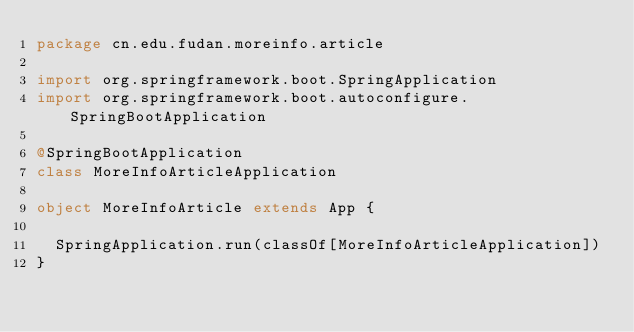Convert code to text. <code><loc_0><loc_0><loc_500><loc_500><_Scala_>package cn.edu.fudan.moreinfo.article

import org.springframework.boot.SpringApplication
import org.springframework.boot.autoconfigure.SpringBootApplication

@SpringBootApplication
class MoreInfoArticleApplication

object MoreInfoArticle extends App {

  SpringApplication.run(classOf[MoreInfoArticleApplication])
}
</code> 